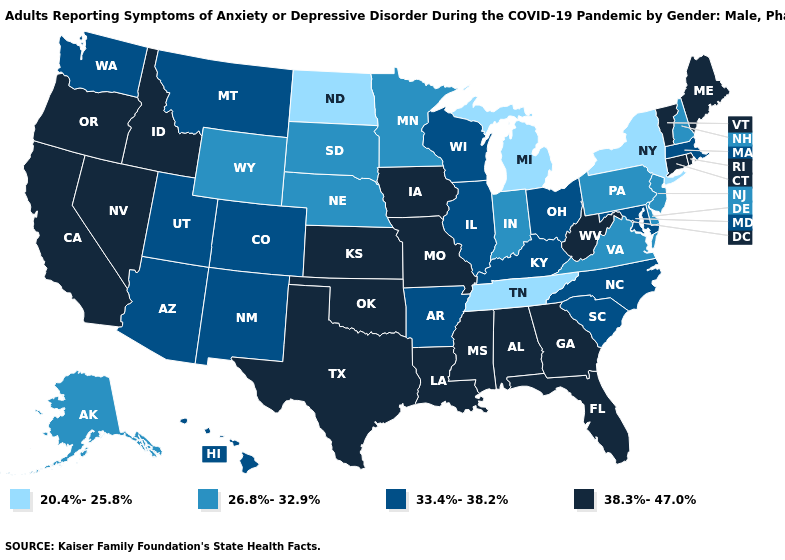What is the value of Minnesota?
Keep it brief. 26.8%-32.9%. What is the value of Mississippi?
Write a very short answer. 38.3%-47.0%. Among the states that border Wyoming , does Colorado have the highest value?
Keep it brief. No. Name the states that have a value in the range 33.4%-38.2%?
Short answer required. Arizona, Arkansas, Colorado, Hawaii, Illinois, Kentucky, Maryland, Massachusetts, Montana, New Mexico, North Carolina, Ohio, South Carolina, Utah, Washington, Wisconsin. What is the value of Hawaii?
Short answer required. 33.4%-38.2%. Name the states that have a value in the range 20.4%-25.8%?
Write a very short answer. Michigan, New York, North Dakota, Tennessee. What is the value of Kentucky?
Short answer required. 33.4%-38.2%. Name the states that have a value in the range 26.8%-32.9%?
Short answer required. Alaska, Delaware, Indiana, Minnesota, Nebraska, New Hampshire, New Jersey, Pennsylvania, South Dakota, Virginia, Wyoming. Which states have the highest value in the USA?
Quick response, please. Alabama, California, Connecticut, Florida, Georgia, Idaho, Iowa, Kansas, Louisiana, Maine, Mississippi, Missouri, Nevada, Oklahoma, Oregon, Rhode Island, Texas, Vermont, West Virginia. Does the map have missing data?
Be succinct. No. Among the states that border Virginia , which have the highest value?
Answer briefly. West Virginia. Which states hav the highest value in the Northeast?
Give a very brief answer. Connecticut, Maine, Rhode Island, Vermont. Name the states that have a value in the range 38.3%-47.0%?
Be succinct. Alabama, California, Connecticut, Florida, Georgia, Idaho, Iowa, Kansas, Louisiana, Maine, Mississippi, Missouri, Nevada, Oklahoma, Oregon, Rhode Island, Texas, Vermont, West Virginia. 